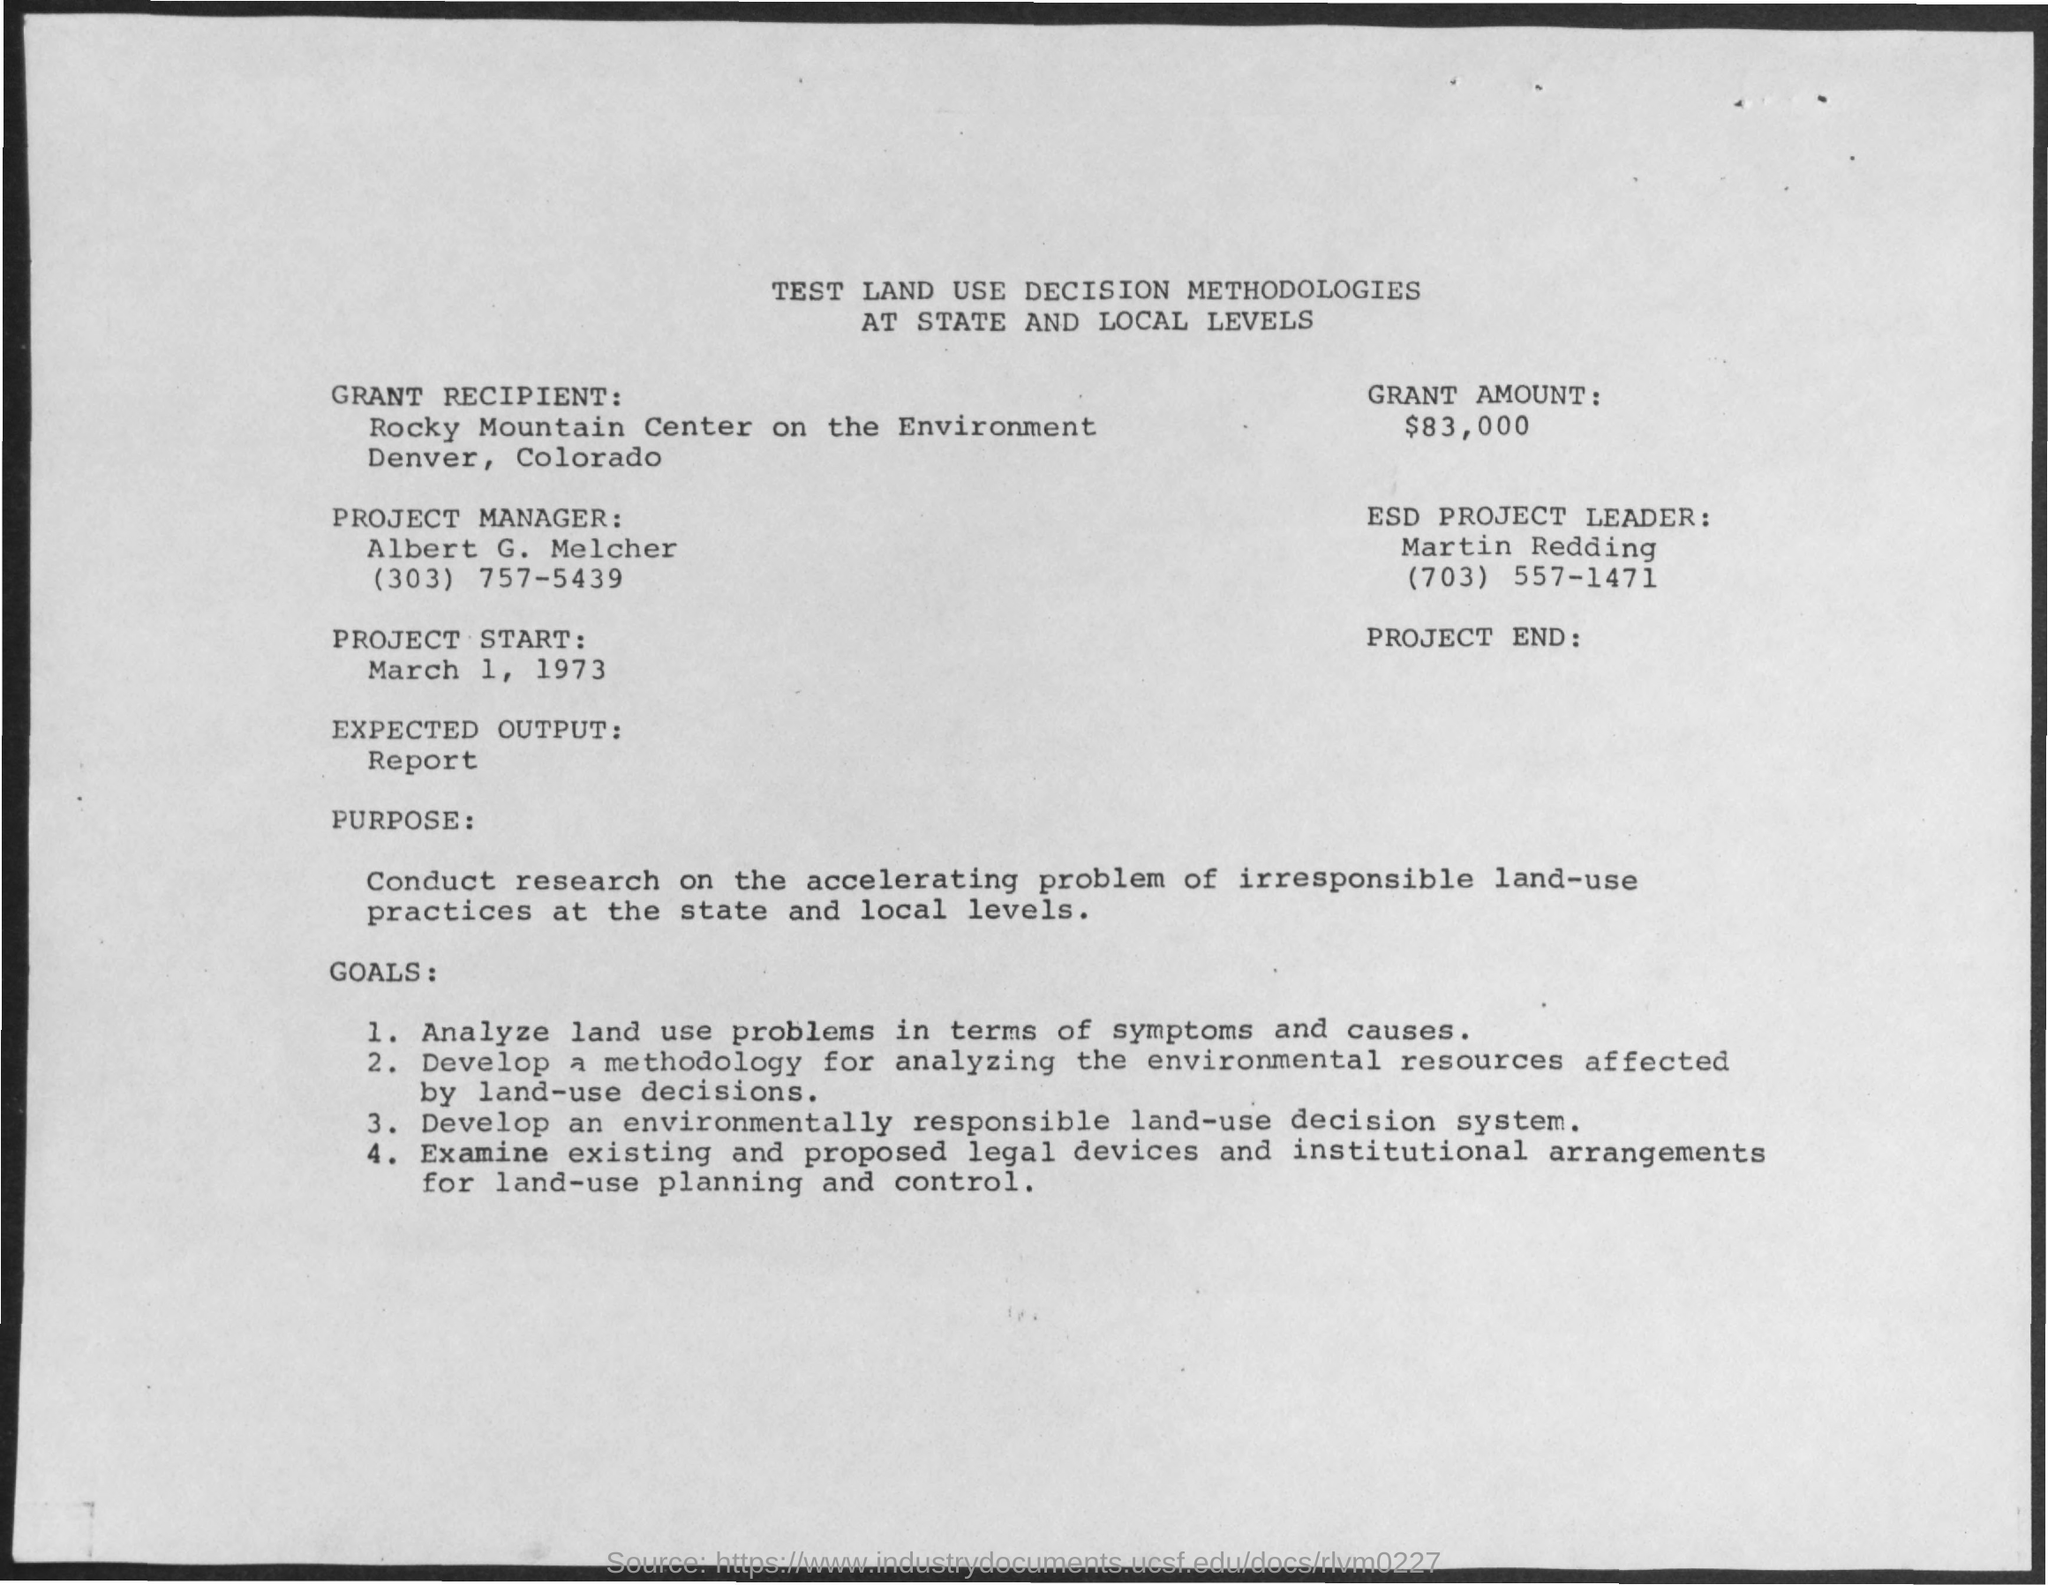Point out several critical features in this image. The contact number of the project manager is (303) 757-5439. The expected output of the program is a report. The project start date is March 1, 1973. The project manager's name is Albert G. Melcher. The contact number of the ESD Project leader is (703) 557-1471. 